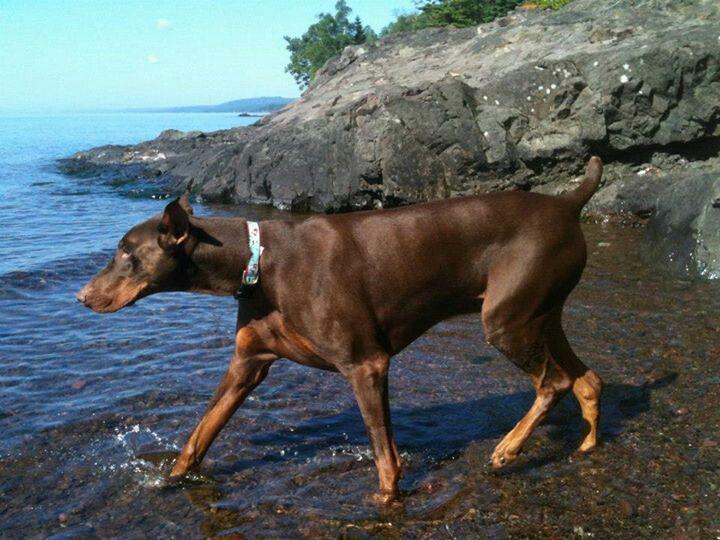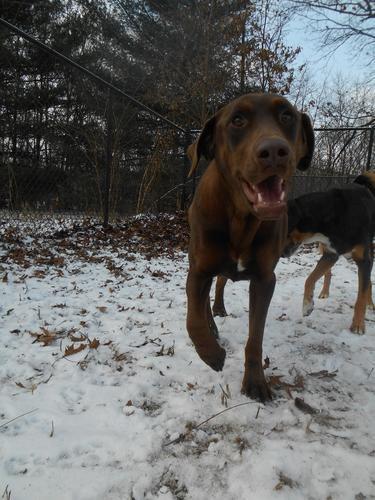The first image is the image on the left, the second image is the image on the right. Examine the images to the left and right. Is the description "All dogs shown are erect-eared dobermans gazing off to the side, and at least one dog is wearing a red collar and has a closed mouth." accurate? Answer yes or no. No. The first image is the image on the left, the second image is the image on the right. Assess this claim about the two images: "The dog in the image on the right has its mouth open.". Correct or not? Answer yes or no. Yes. 